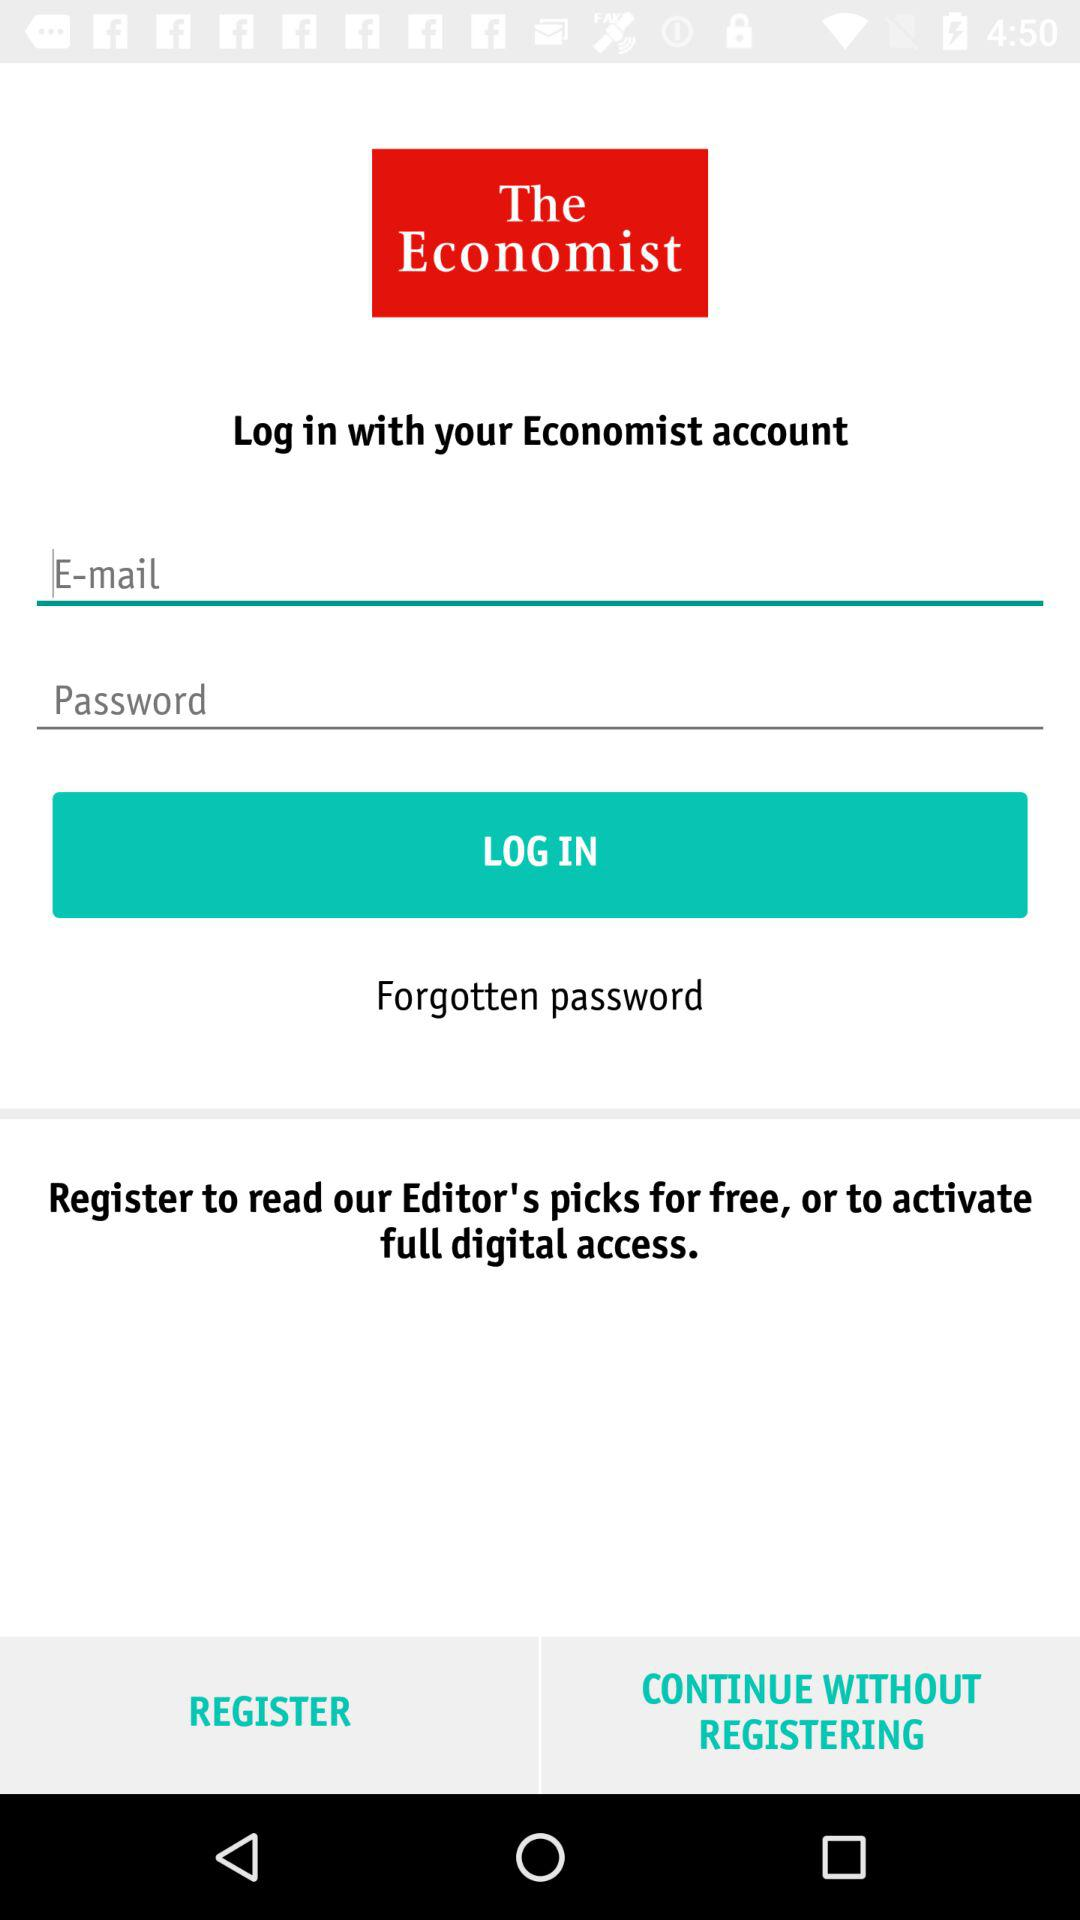How many input fields are there for logging in?
Answer the question using a single word or phrase. 2 